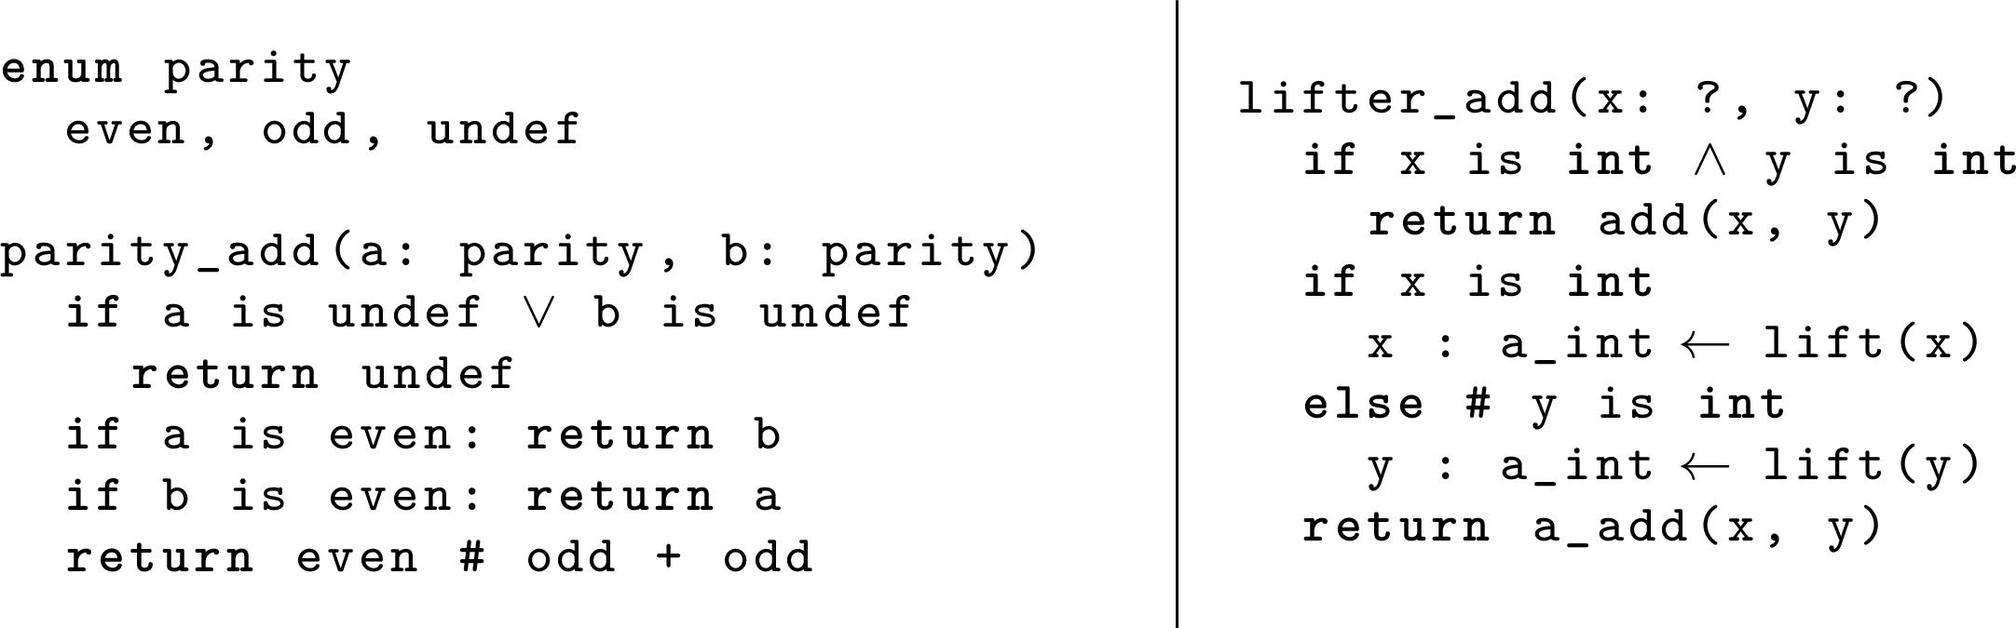In the `parity_add` function, if `a` is `even` and `b` is `undef`, what will the function return? A. even B. odd C. undef D. b The first conditional check in the `parity_add` function is whether either `a` or `b` is `undef`. If either is `undef`, the function will return `undef` regardless of the other input's value. Therefore, the correct answer is C. 